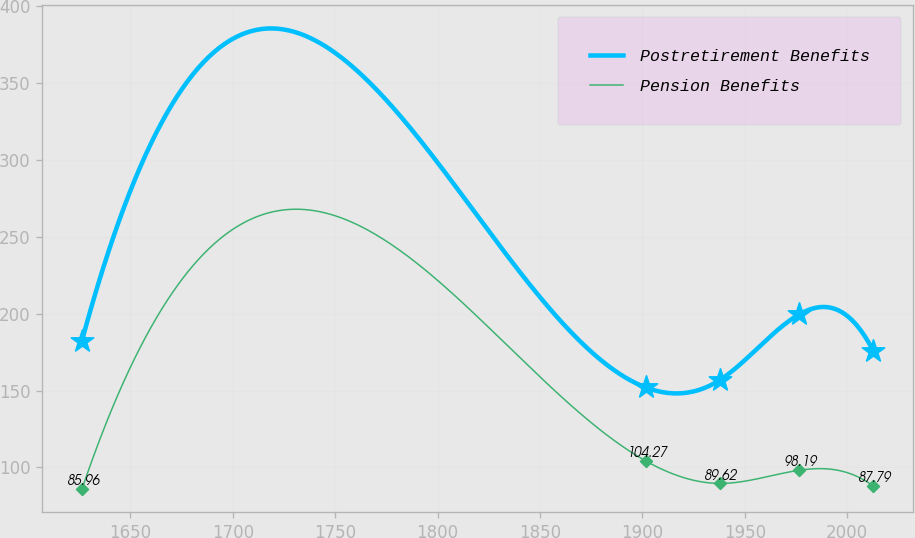<chart> <loc_0><loc_0><loc_500><loc_500><line_chart><ecel><fcel>Postretirement Benefits<fcel>Pension Benefits<nl><fcel>1626.37<fcel>182.46<fcel>85.96<nl><fcel>1901.61<fcel>152.05<fcel>104.27<nl><fcel>1937.8<fcel>156.8<fcel>89.62<nl><fcel>1976.68<fcel>199.59<fcel>98.19<nl><fcel>2012.87<fcel>175.46<fcel>87.79<nl></chart> 